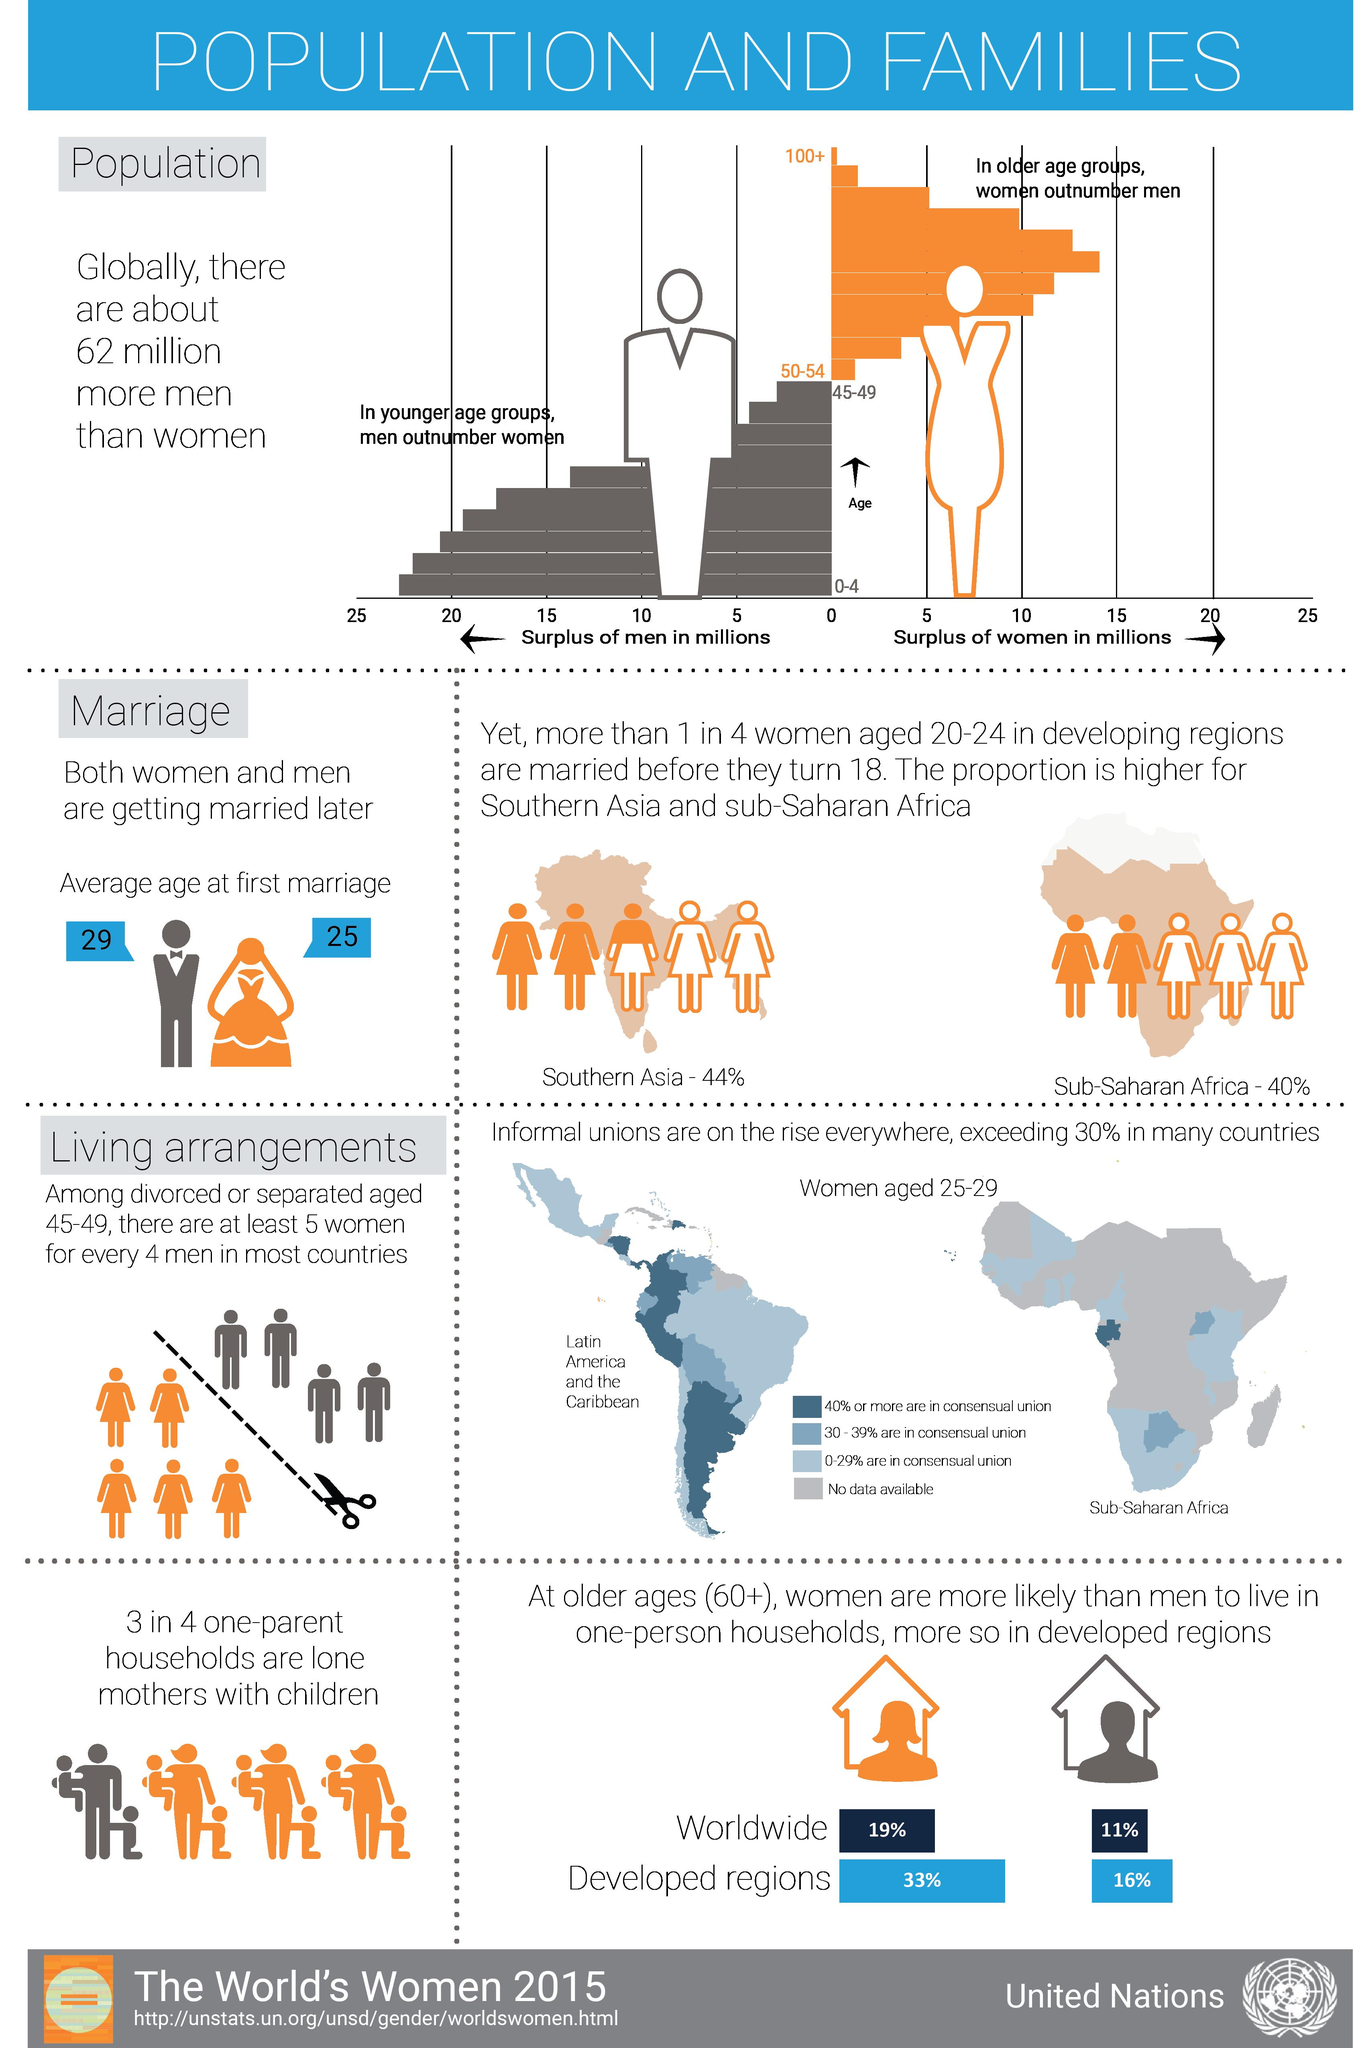Identify some key points in this picture. In developing regions, approximately 25% of women aged 20-24 who are married before they turn 18. The color representing men in the graph is grey. The color that represents women in the graph is orange. According to the data, women aged 60 and above in developed regions are more likely to live in one-person households than men, with a significant 17% difference. According to recent data, a significant proportion of one-parent households consist of single mothers with children, with 75% of such households being headed by a single mother. 